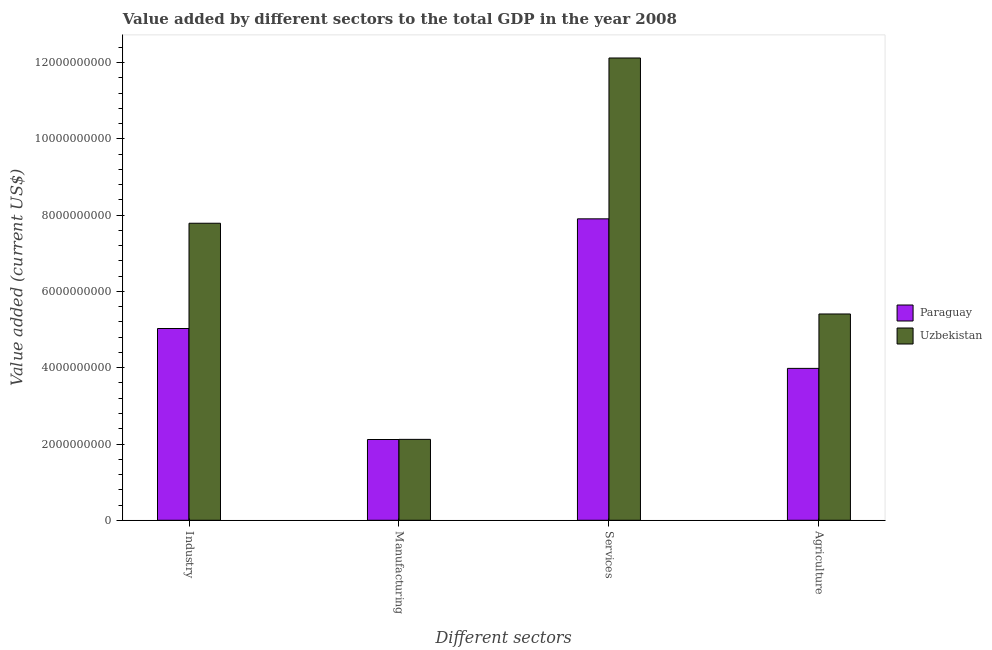Are the number of bars on each tick of the X-axis equal?
Give a very brief answer. Yes. How many bars are there on the 4th tick from the left?
Your response must be concise. 2. How many bars are there on the 2nd tick from the right?
Offer a very short reply. 2. What is the label of the 1st group of bars from the left?
Offer a very short reply. Industry. What is the value added by manufacturing sector in Uzbekistan?
Your answer should be compact. 2.12e+09. Across all countries, what is the maximum value added by services sector?
Provide a succinct answer. 1.21e+1. Across all countries, what is the minimum value added by industrial sector?
Ensure brevity in your answer.  5.03e+09. In which country was the value added by industrial sector maximum?
Offer a very short reply. Uzbekistan. In which country was the value added by industrial sector minimum?
Your response must be concise. Paraguay. What is the total value added by industrial sector in the graph?
Your response must be concise. 1.28e+1. What is the difference between the value added by services sector in Uzbekistan and that in Paraguay?
Your answer should be compact. 4.22e+09. What is the difference between the value added by services sector in Uzbekistan and the value added by agricultural sector in Paraguay?
Ensure brevity in your answer.  8.14e+09. What is the average value added by industrial sector per country?
Provide a succinct answer. 6.41e+09. What is the difference between the value added by industrial sector and value added by services sector in Paraguay?
Give a very brief answer. -2.88e+09. What is the ratio of the value added by agricultural sector in Uzbekistan to that in Paraguay?
Give a very brief answer. 1.36. What is the difference between the highest and the second highest value added by services sector?
Offer a very short reply. 4.22e+09. What is the difference between the highest and the lowest value added by agricultural sector?
Make the answer very short. 1.43e+09. In how many countries, is the value added by agricultural sector greater than the average value added by agricultural sector taken over all countries?
Ensure brevity in your answer.  1. Is the sum of the value added by manufacturing sector in Uzbekistan and Paraguay greater than the maximum value added by agricultural sector across all countries?
Your answer should be compact. No. Is it the case that in every country, the sum of the value added by agricultural sector and value added by industrial sector is greater than the sum of value added by services sector and value added by manufacturing sector?
Your answer should be compact. No. What does the 1st bar from the left in Agriculture represents?
Your answer should be compact. Paraguay. What does the 2nd bar from the right in Manufacturing represents?
Keep it short and to the point. Paraguay. Are all the bars in the graph horizontal?
Keep it short and to the point. No. Does the graph contain grids?
Make the answer very short. No. Where does the legend appear in the graph?
Keep it short and to the point. Center right. How are the legend labels stacked?
Provide a short and direct response. Vertical. What is the title of the graph?
Provide a succinct answer. Value added by different sectors to the total GDP in the year 2008. Does "St. Vincent and the Grenadines" appear as one of the legend labels in the graph?
Keep it short and to the point. No. What is the label or title of the X-axis?
Keep it short and to the point. Different sectors. What is the label or title of the Y-axis?
Ensure brevity in your answer.  Value added (current US$). What is the Value added (current US$) of Paraguay in Industry?
Provide a succinct answer. 5.03e+09. What is the Value added (current US$) of Uzbekistan in Industry?
Your response must be concise. 7.79e+09. What is the Value added (current US$) in Paraguay in Manufacturing?
Provide a succinct answer. 2.12e+09. What is the Value added (current US$) of Uzbekistan in Manufacturing?
Ensure brevity in your answer.  2.12e+09. What is the Value added (current US$) in Paraguay in Services?
Ensure brevity in your answer.  7.91e+09. What is the Value added (current US$) of Uzbekistan in Services?
Provide a short and direct response. 1.21e+1. What is the Value added (current US$) of Paraguay in Agriculture?
Your answer should be compact. 3.98e+09. What is the Value added (current US$) of Uzbekistan in Agriculture?
Your answer should be compact. 5.41e+09. Across all Different sectors, what is the maximum Value added (current US$) in Paraguay?
Offer a terse response. 7.91e+09. Across all Different sectors, what is the maximum Value added (current US$) in Uzbekistan?
Provide a succinct answer. 1.21e+1. Across all Different sectors, what is the minimum Value added (current US$) in Paraguay?
Ensure brevity in your answer.  2.12e+09. Across all Different sectors, what is the minimum Value added (current US$) of Uzbekistan?
Offer a very short reply. 2.12e+09. What is the total Value added (current US$) in Paraguay in the graph?
Your answer should be very brief. 1.90e+1. What is the total Value added (current US$) in Uzbekistan in the graph?
Your answer should be very brief. 2.74e+1. What is the difference between the Value added (current US$) in Paraguay in Industry and that in Manufacturing?
Keep it short and to the point. 2.91e+09. What is the difference between the Value added (current US$) in Uzbekistan in Industry and that in Manufacturing?
Provide a short and direct response. 5.67e+09. What is the difference between the Value added (current US$) of Paraguay in Industry and that in Services?
Make the answer very short. -2.88e+09. What is the difference between the Value added (current US$) in Uzbekistan in Industry and that in Services?
Provide a short and direct response. -4.33e+09. What is the difference between the Value added (current US$) of Paraguay in Industry and that in Agriculture?
Your response must be concise. 1.05e+09. What is the difference between the Value added (current US$) in Uzbekistan in Industry and that in Agriculture?
Provide a succinct answer. 2.38e+09. What is the difference between the Value added (current US$) in Paraguay in Manufacturing and that in Services?
Keep it short and to the point. -5.79e+09. What is the difference between the Value added (current US$) of Uzbekistan in Manufacturing and that in Services?
Offer a terse response. -1.00e+1. What is the difference between the Value added (current US$) in Paraguay in Manufacturing and that in Agriculture?
Give a very brief answer. -1.87e+09. What is the difference between the Value added (current US$) in Uzbekistan in Manufacturing and that in Agriculture?
Keep it short and to the point. -3.29e+09. What is the difference between the Value added (current US$) in Paraguay in Services and that in Agriculture?
Your answer should be compact. 3.92e+09. What is the difference between the Value added (current US$) of Uzbekistan in Services and that in Agriculture?
Provide a short and direct response. 6.71e+09. What is the difference between the Value added (current US$) in Paraguay in Industry and the Value added (current US$) in Uzbekistan in Manufacturing?
Provide a succinct answer. 2.91e+09. What is the difference between the Value added (current US$) of Paraguay in Industry and the Value added (current US$) of Uzbekistan in Services?
Provide a short and direct response. -7.09e+09. What is the difference between the Value added (current US$) in Paraguay in Industry and the Value added (current US$) in Uzbekistan in Agriculture?
Provide a succinct answer. -3.81e+08. What is the difference between the Value added (current US$) of Paraguay in Manufacturing and the Value added (current US$) of Uzbekistan in Services?
Your response must be concise. -1.00e+1. What is the difference between the Value added (current US$) of Paraguay in Manufacturing and the Value added (current US$) of Uzbekistan in Agriculture?
Ensure brevity in your answer.  -3.29e+09. What is the difference between the Value added (current US$) in Paraguay in Services and the Value added (current US$) in Uzbekistan in Agriculture?
Offer a terse response. 2.50e+09. What is the average Value added (current US$) of Paraguay per Different sectors?
Ensure brevity in your answer.  4.76e+09. What is the average Value added (current US$) of Uzbekistan per Different sectors?
Your response must be concise. 6.86e+09. What is the difference between the Value added (current US$) of Paraguay and Value added (current US$) of Uzbekistan in Industry?
Give a very brief answer. -2.76e+09. What is the difference between the Value added (current US$) of Paraguay and Value added (current US$) of Uzbekistan in Manufacturing?
Make the answer very short. -3.38e+06. What is the difference between the Value added (current US$) in Paraguay and Value added (current US$) in Uzbekistan in Services?
Keep it short and to the point. -4.22e+09. What is the difference between the Value added (current US$) in Paraguay and Value added (current US$) in Uzbekistan in Agriculture?
Ensure brevity in your answer.  -1.43e+09. What is the ratio of the Value added (current US$) of Paraguay in Industry to that in Manufacturing?
Keep it short and to the point. 2.37. What is the ratio of the Value added (current US$) of Uzbekistan in Industry to that in Manufacturing?
Keep it short and to the point. 3.67. What is the ratio of the Value added (current US$) in Paraguay in Industry to that in Services?
Your response must be concise. 0.64. What is the ratio of the Value added (current US$) of Uzbekistan in Industry to that in Services?
Offer a terse response. 0.64. What is the ratio of the Value added (current US$) in Paraguay in Industry to that in Agriculture?
Offer a very short reply. 1.26. What is the ratio of the Value added (current US$) of Uzbekistan in Industry to that in Agriculture?
Provide a succinct answer. 1.44. What is the ratio of the Value added (current US$) of Paraguay in Manufacturing to that in Services?
Your response must be concise. 0.27. What is the ratio of the Value added (current US$) of Uzbekistan in Manufacturing to that in Services?
Your answer should be compact. 0.17. What is the ratio of the Value added (current US$) of Paraguay in Manufacturing to that in Agriculture?
Your response must be concise. 0.53. What is the ratio of the Value added (current US$) in Uzbekistan in Manufacturing to that in Agriculture?
Offer a terse response. 0.39. What is the ratio of the Value added (current US$) in Paraguay in Services to that in Agriculture?
Your answer should be very brief. 1.98. What is the ratio of the Value added (current US$) in Uzbekistan in Services to that in Agriculture?
Offer a terse response. 2.24. What is the difference between the highest and the second highest Value added (current US$) of Paraguay?
Offer a terse response. 2.88e+09. What is the difference between the highest and the second highest Value added (current US$) in Uzbekistan?
Your answer should be very brief. 4.33e+09. What is the difference between the highest and the lowest Value added (current US$) in Paraguay?
Provide a short and direct response. 5.79e+09. What is the difference between the highest and the lowest Value added (current US$) in Uzbekistan?
Provide a succinct answer. 1.00e+1. 